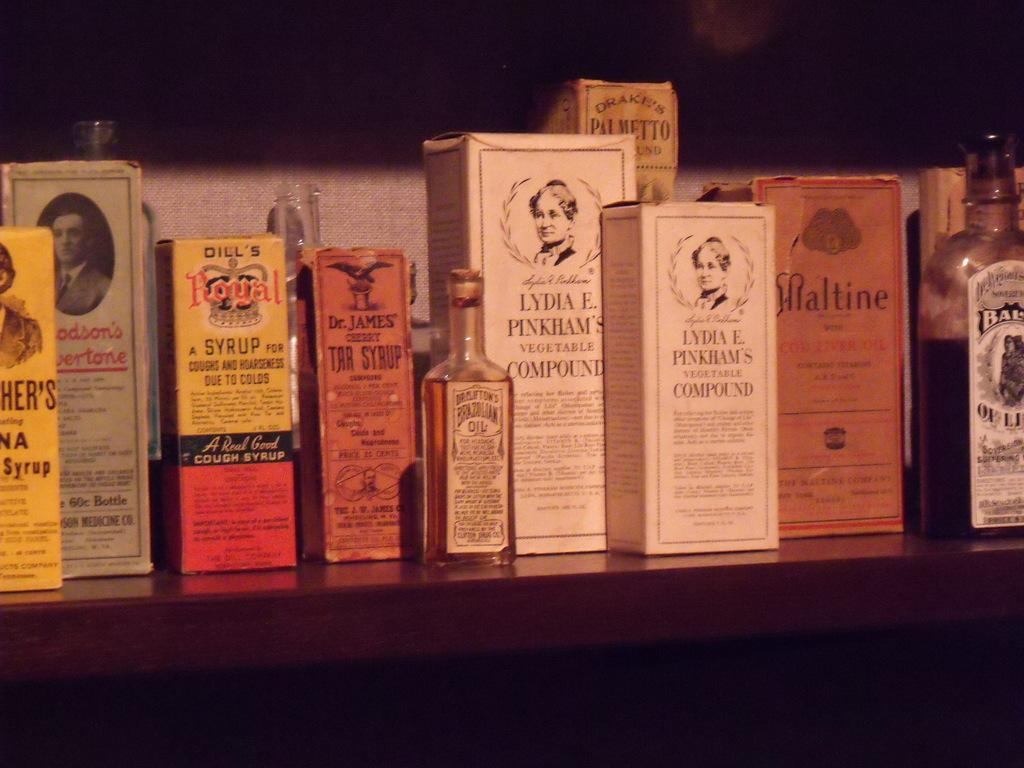<image>
Give a short and clear explanation of the subsequent image. a bottle of Brazilian Oil  sits next a box of Lydia E. Pinkham's vegetable compound 